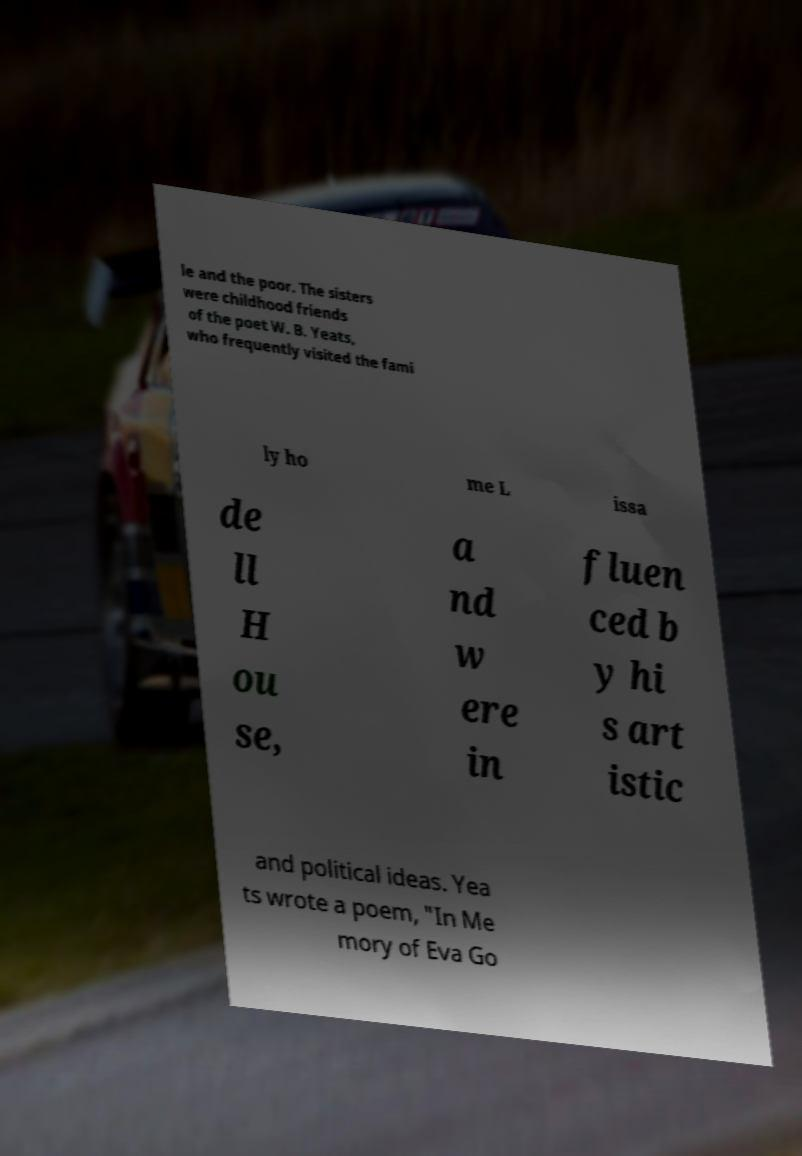Could you extract and type out the text from this image? le and the poor. The sisters were childhood friends of the poet W. B. Yeats, who frequently visited the fami ly ho me L issa de ll H ou se, a nd w ere in fluen ced b y hi s art istic and political ideas. Yea ts wrote a poem, "In Me mory of Eva Go 